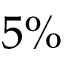Convert formula to latex. <formula><loc_0><loc_0><loc_500><loc_500>5 \%</formula> 